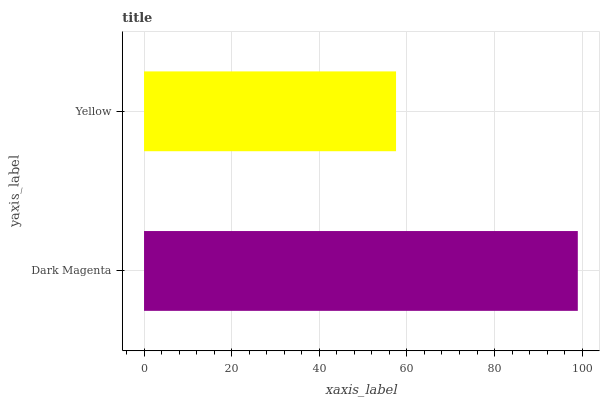Is Yellow the minimum?
Answer yes or no. Yes. Is Dark Magenta the maximum?
Answer yes or no. Yes. Is Yellow the maximum?
Answer yes or no. No. Is Dark Magenta greater than Yellow?
Answer yes or no. Yes. Is Yellow less than Dark Magenta?
Answer yes or no. Yes. Is Yellow greater than Dark Magenta?
Answer yes or no. No. Is Dark Magenta less than Yellow?
Answer yes or no. No. Is Dark Magenta the high median?
Answer yes or no. Yes. Is Yellow the low median?
Answer yes or no. Yes. Is Yellow the high median?
Answer yes or no. No. Is Dark Magenta the low median?
Answer yes or no. No. 